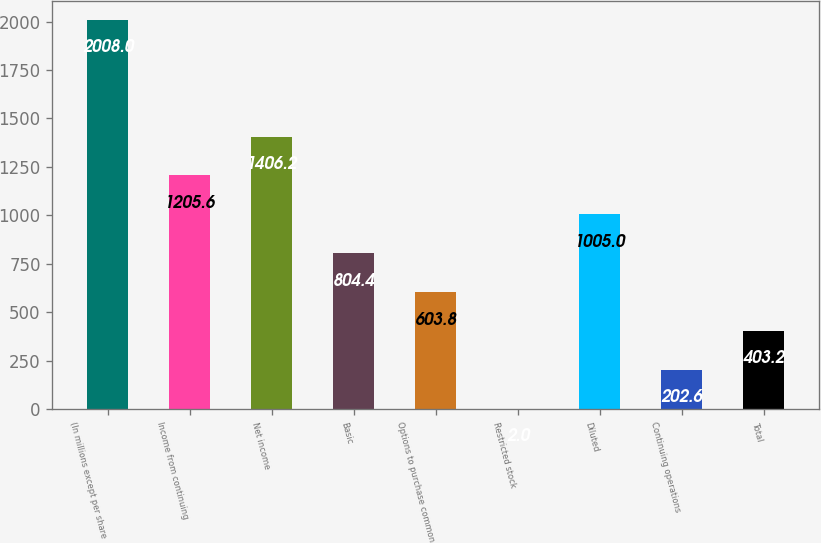Convert chart. <chart><loc_0><loc_0><loc_500><loc_500><bar_chart><fcel>(In millions except per share<fcel>Income from continuing<fcel>Net income<fcel>Basic<fcel>Options to purchase common<fcel>Restricted stock<fcel>Diluted<fcel>Continuing operations<fcel>Total<nl><fcel>2008<fcel>1205.6<fcel>1406.2<fcel>804.4<fcel>603.8<fcel>2<fcel>1005<fcel>202.6<fcel>403.2<nl></chart> 